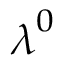Convert formula to latex. <formula><loc_0><loc_0><loc_500><loc_500>\lambda ^ { 0 }</formula> 